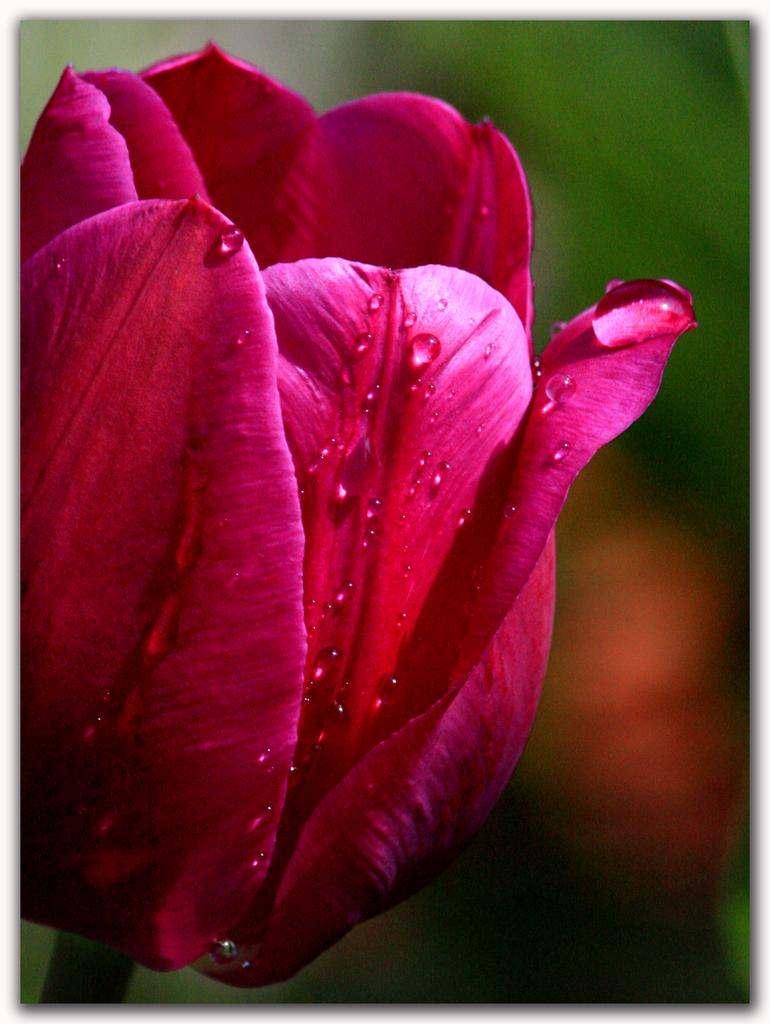What type of flower is present in the image? There is a pink color flower in the image. Can you describe the background of the image? The background of the image is blurred. How many goldfish can be seen swimming in the stream in the image? There is no stream or goldfish present in the image; it features a pink color flower with a blurred background. 